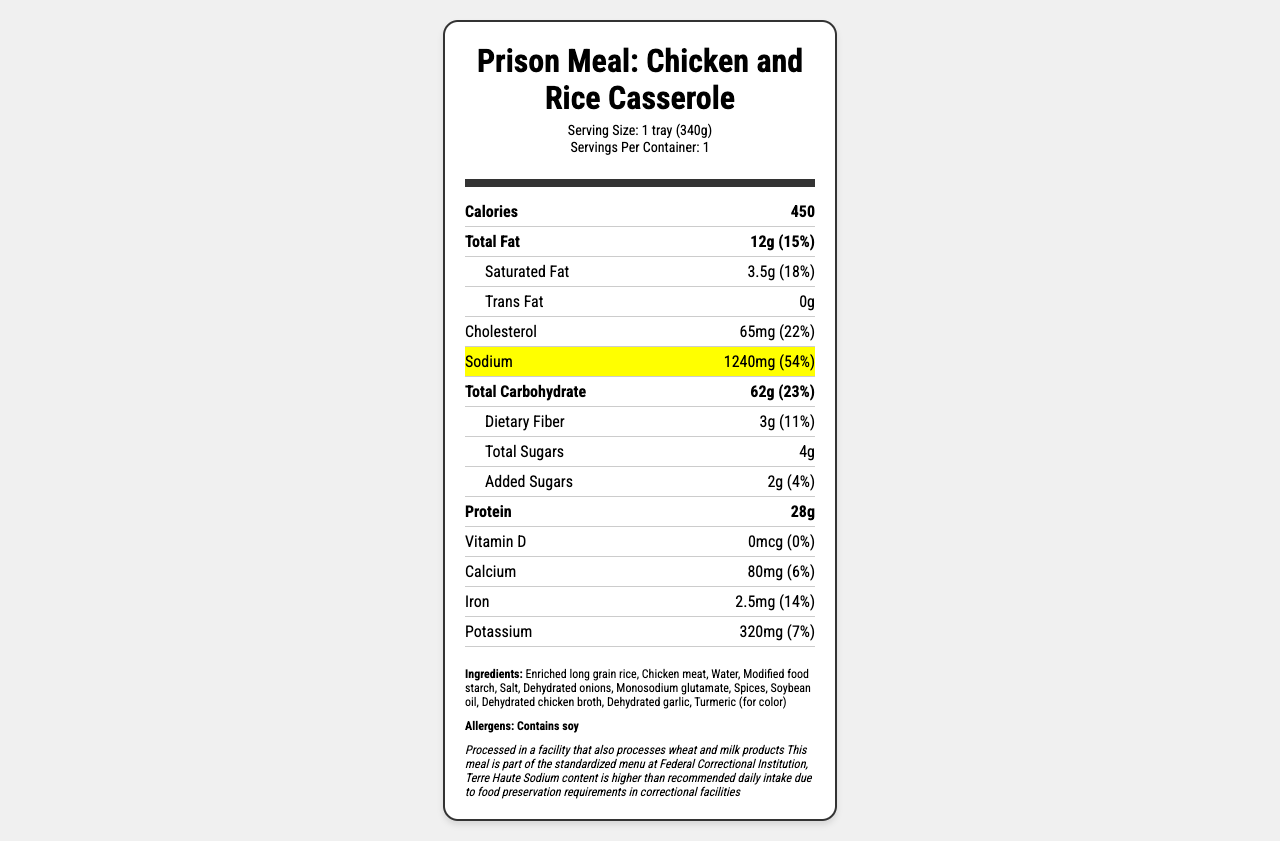what is the serving size in grams? The serving size is clearly stated as "1 tray (340g)" in the document.
Answer: 340g what is the sodium content per serving in milligrams? The sodium content is highlighted in the document, showing 1240mg per serving.
Answer: 1240mg how much protein does the meal contain? The amount of protein is listed as 28g per serving in the document.
Answer: 28g what percentage of the daily value of saturated fat is in one serving? The saturated fat daily value percentage is given as 18% in the document.
Answer: 18% how much added sugars are in the meal? The total amount of added sugars is listed as 2g in the document.
Answer: 2g how much iron is in the prison meal? A. 1.5mg B. 2.5mg C. 3.5mg D. 4.5mg The document states that the prison meal contains 2.5mg of iron.
Answer: B. 2.5mg which ingredient is used for color in the meal? A. Modified food starch B. Turmeric C. Dehydrated garlic The ingredient list specifies "Turmeric (for color)".
Answer: B. Turmeric does the meal contain monosodium glutamate? The ingredient list includes "Monosodium glutamate".
Answer: Yes describe the key nutrition facts of the prison meal. This summary encapsulates the primary nutritional data provided in the document, including the significant macronutrients and micronutrients as well as the ingredient list and allergen information.
Answer: The prison meal "Chicken and Rice Casserole" has a serving size of 1 tray (340g) and contains 450 calories per serving. It has 12g of total fat (15% DV), 3.5g of saturated fat (18% DV), 0g of trans fat, 65mg of cholesterol (22% DV), and an elevated sodium content of 1240mg (54% DV). The total carbohydrate content is 62g (23% DV), including 3g of dietary fiber (11% DV) and 4g of total sugars (with 2g added sugars). The meal also has 28g of protein and contains traces of vitamin D (0mcg), calcium (80mg, 6% DV), iron (2.5mg, 14% DV), and potassium (320mg, 7% DV). The ingredients include enriched long grain rice, chicken meat, and various dehydrated seasonings, with soy listed as an allergen. it mentions that the sodium content is part of the standardized menu. which correctional facility is it referring to? The additional information section specifies that this meal is part of the standardized menu at Federal Correctional Institution, Terre Haute.
Answer: Federal Correctional Institution, Terre Haute how is the meal preserved? The document indicates that the high sodium content is due to preservation requirements, but it does not specify the exact methods used for preservation.
Answer: Not enough information 